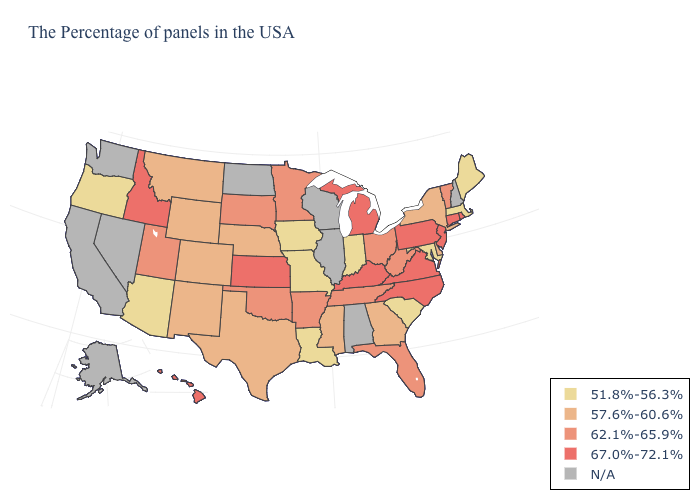What is the highest value in states that border Florida?
Keep it brief. 57.6%-60.6%. What is the value of Washington?
Keep it brief. N/A. What is the value of South Dakota?
Be succinct. 62.1%-65.9%. Among the states that border Wisconsin , does Iowa have the highest value?
Short answer required. No. Name the states that have a value in the range N/A?
Write a very short answer. New Hampshire, Alabama, Wisconsin, Illinois, North Dakota, Nevada, California, Washington, Alaska. What is the value of New Jersey?
Keep it brief. 67.0%-72.1%. What is the value of North Carolina?
Quick response, please. 67.0%-72.1%. What is the highest value in states that border West Virginia?
Keep it brief. 67.0%-72.1%. What is the value of Georgia?
Concise answer only. 57.6%-60.6%. Among the states that border Maryland , which have the highest value?
Concise answer only. Pennsylvania, Virginia. Among the states that border Louisiana , which have the highest value?
Keep it brief. Arkansas. Among the states that border Ohio , which have the highest value?
Concise answer only. Pennsylvania, Michigan, Kentucky. What is the lowest value in the South?
Short answer required. 51.8%-56.3%. Does Virginia have the highest value in the South?
Write a very short answer. Yes. Among the states that border Florida , which have the lowest value?
Short answer required. Georgia. 